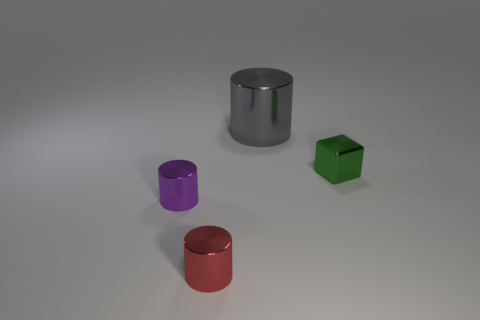Subtract 1 cylinders. How many cylinders are left? 2 Add 1 small objects. How many objects exist? 5 Subtract all cylinders. How many objects are left? 1 Add 3 big gray things. How many big gray things exist? 4 Subtract 0 purple balls. How many objects are left? 4 Subtract all tiny red things. Subtract all small yellow balls. How many objects are left? 3 Add 4 red shiny cylinders. How many red shiny cylinders are left? 5 